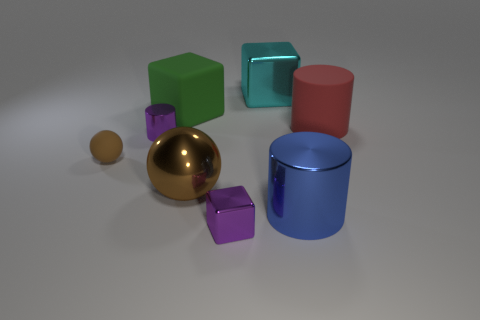Is the material of the green object the same as the red object?
Ensure brevity in your answer.  Yes. What number of rubber cylinders are right of the red rubber cylinder right of the big brown sphere?
Make the answer very short. 0. Do the block in front of the red matte cylinder and the small cylinder have the same color?
Your response must be concise. Yes. What number of objects are big cyan things or rubber objects to the left of the cyan shiny cube?
Provide a succinct answer. 3. Do the tiny thing that is in front of the large sphere and the metallic object behind the matte block have the same shape?
Offer a very short reply. Yes. Is there anything else of the same color as the large rubber block?
Keep it short and to the point. No. There is a big blue object that is made of the same material as the small purple block; what shape is it?
Your answer should be compact. Cylinder. What is the thing that is both on the right side of the large shiny cube and to the left of the large red object made of?
Provide a short and direct response. Metal. Does the tiny block have the same color as the small metal cylinder?
Your answer should be very brief. Yes. There is a tiny matte thing that is the same color as the shiny ball; what is its shape?
Make the answer very short. Sphere. 